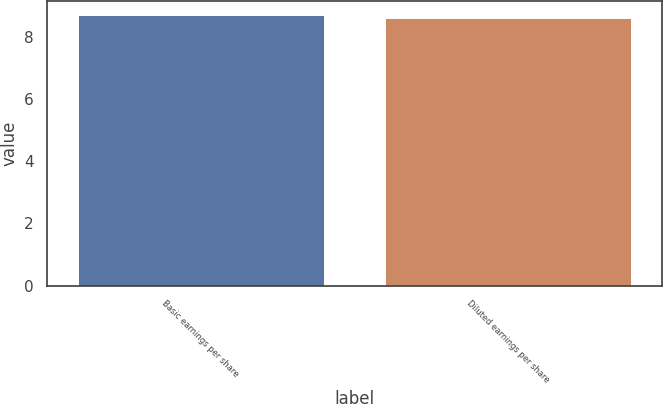Convert chart. <chart><loc_0><loc_0><loc_500><loc_500><bar_chart><fcel>Basic earnings per share<fcel>Diluted earnings per share<nl><fcel>8.71<fcel>8.61<nl></chart> 